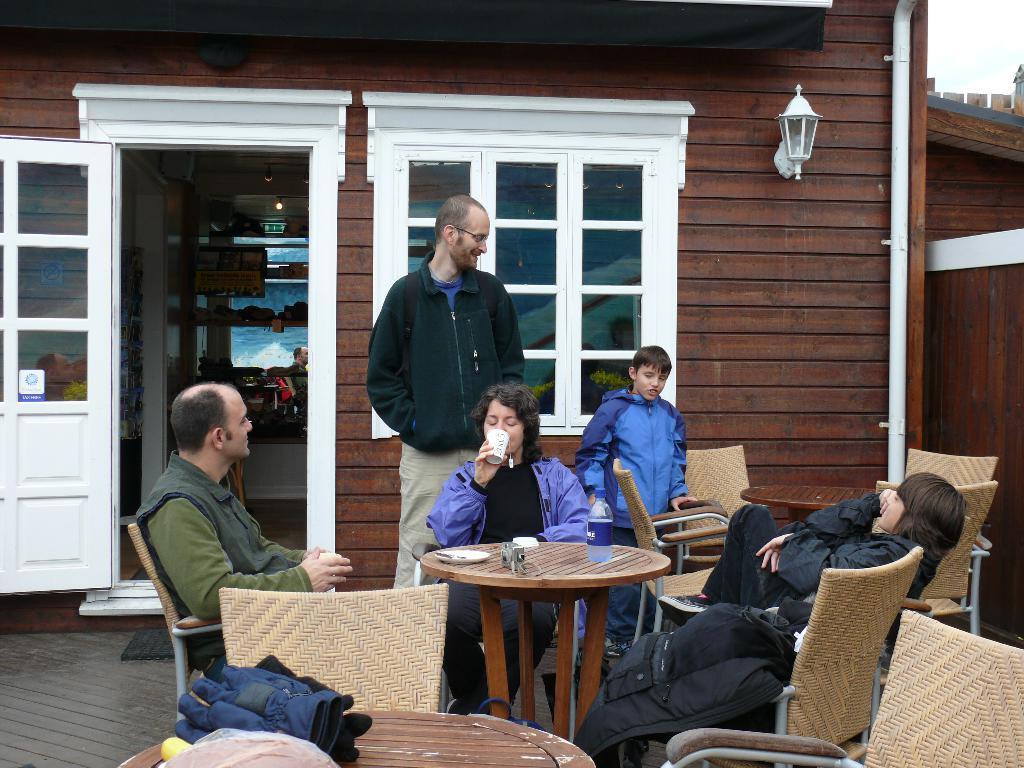Please provide a concise description of this image. In this image few people are sitting on the chair. The man is standing. On the table there are gloves. At the back side we can see a building. 